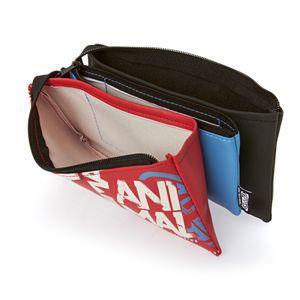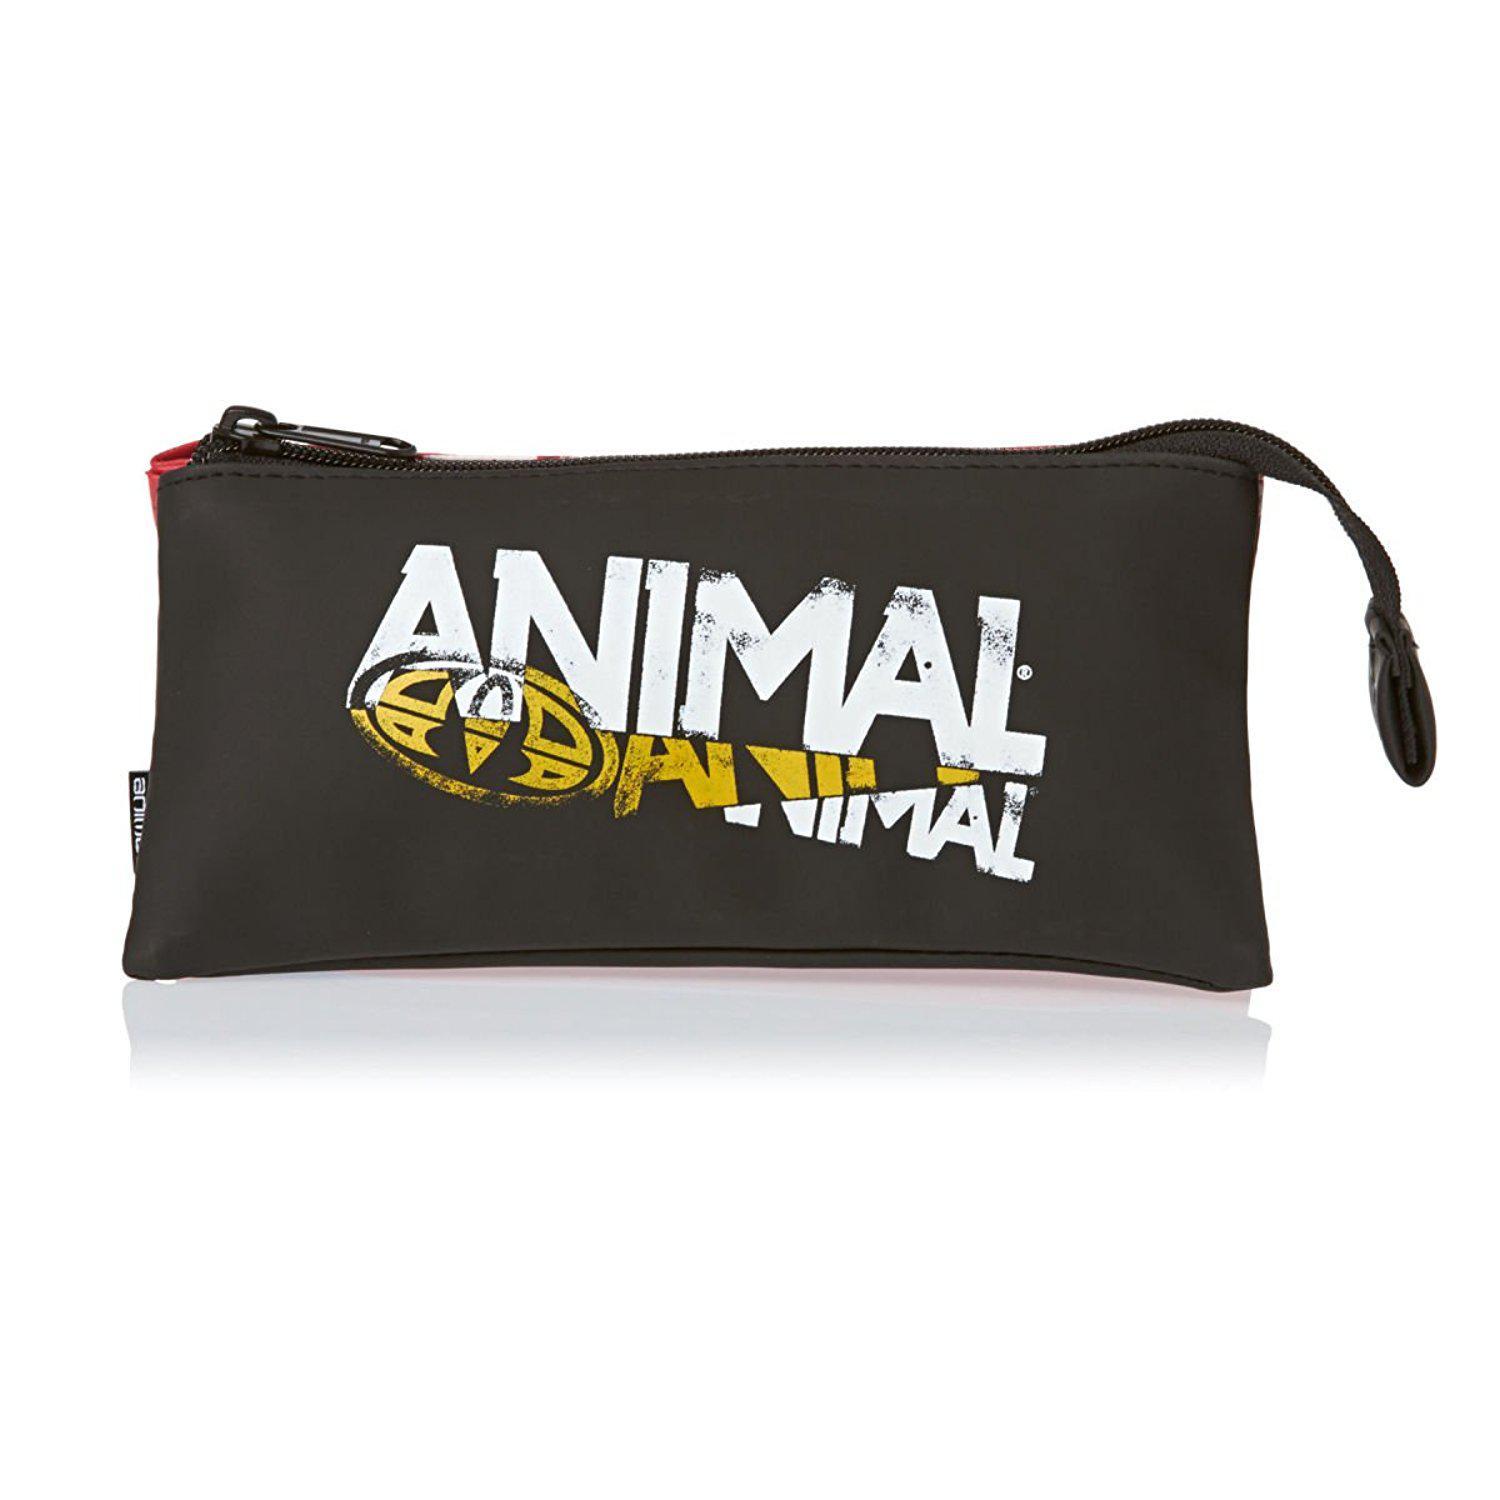The first image is the image on the left, the second image is the image on the right. For the images displayed, is the sentence "At least one of the pencil cases is red, and all pencil cases with a visible front feature bold lettering." factually correct? Answer yes or no. Yes. The first image is the image on the left, the second image is the image on the right. Assess this claim about the two images: "Two rectangular shaped closed bags are decorated with different designs, but both have a visible zipper pull at one end and the zipper tag hanging down on the other end.". Correct or not? Answer yes or no. No. 